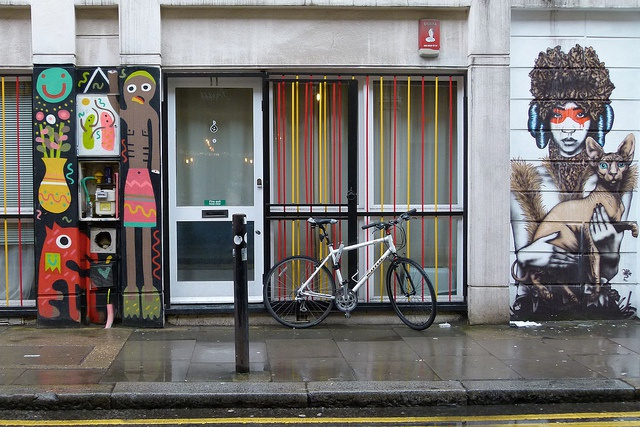Describe the objects in this image and their specific colors. I can see bicycle in lightgray, gray, black, and darkgray tones, cat in lightgray, black, gray, darkgray, and tan tones, and vase in lightgray, gold, orange, salmon, and black tones in this image. 